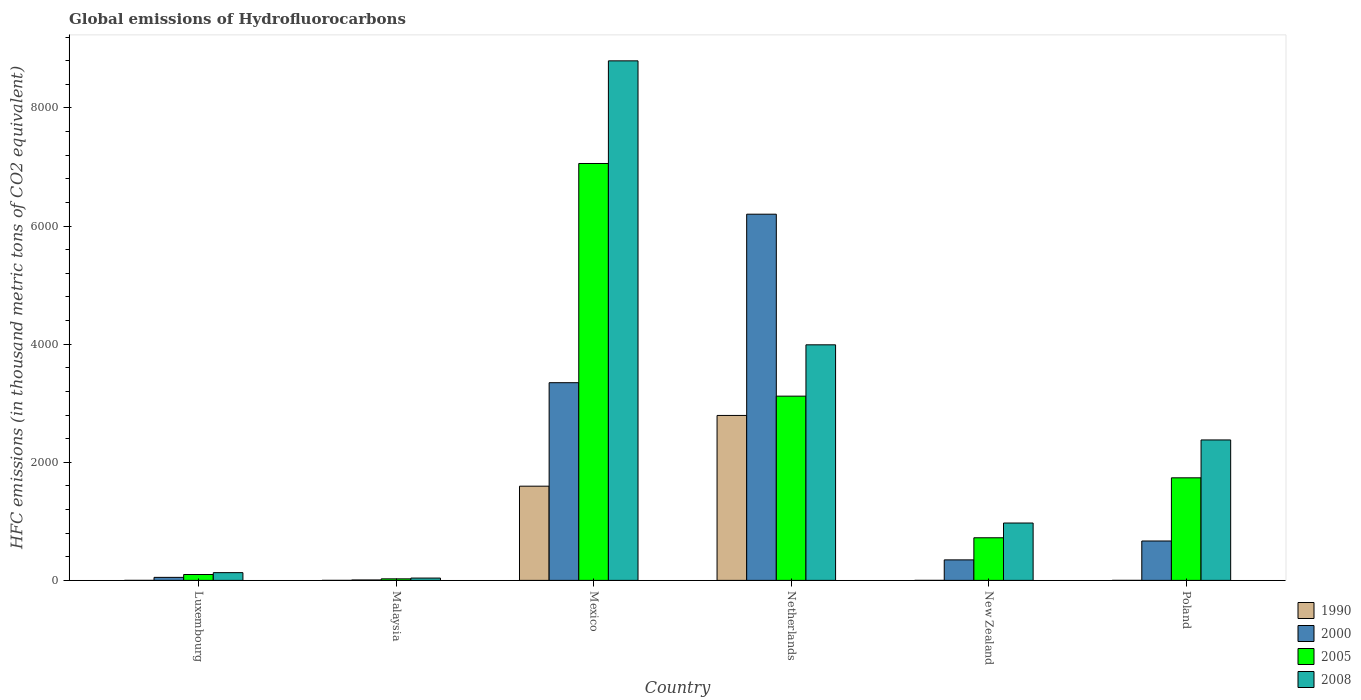How many different coloured bars are there?
Provide a short and direct response. 4. Are the number of bars on each tick of the X-axis equal?
Offer a very short reply. Yes. What is the label of the 4th group of bars from the left?
Offer a terse response. Netherlands. What is the global emissions of Hydrofluorocarbons in 2000 in Luxembourg?
Your response must be concise. 51.1. Across all countries, what is the maximum global emissions of Hydrofluorocarbons in 1990?
Keep it short and to the point. 2792.9. Across all countries, what is the minimum global emissions of Hydrofluorocarbons in 2005?
Your answer should be compact. 26.1. In which country was the global emissions of Hydrofluorocarbons in 2005 minimum?
Offer a very short reply. Malaysia. What is the total global emissions of Hydrofluorocarbons in 1990 in the graph?
Keep it short and to the point. 4388.7. What is the difference between the global emissions of Hydrofluorocarbons in 2005 in Mexico and that in Poland?
Offer a very short reply. 5322.2. What is the difference between the global emissions of Hydrofluorocarbons in 1990 in Malaysia and the global emissions of Hydrofluorocarbons in 2000 in Mexico?
Offer a very short reply. -3347.2. What is the average global emissions of Hydrofluorocarbons in 2000 per country?
Your answer should be compact. 1770.03. What is the difference between the global emissions of Hydrofluorocarbons of/in 2005 and global emissions of Hydrofluorocarbons of/in 2000 in Malaysia?
Provide a short and direct response. 19.2. In how many countries, is the global emissions of Hydrofluorocarbons in 1990 greater than 4800 thousand metric tons?
Make the answer very short. 0. What is the ratio of the global emissions of Hydrofluorocarbons in 2000 in Malaysia to that in New Zealand?
Your answer should be compact. 0.02. Is the global emissions of Hydrofluorocarbons in 1990 in Malaysia less than that in Poland?
Provide a succinct answer. No. What is the difference between the highest and the second highest global emissions of Hydrofluorocarbons in 2000?
Your answer should be compact. 2853.1. What is the difference between the highest and the lowest global emissions of Hydrofluorocarbons in 2000?
Ensure brevity in your answer.  6193.5. In how many countries, is the global emissions of Hydrofluorocarbons in 1990 greater than the average global emissions of Hydrofluorocarbons in 1990 taken over all countries?
Make the answer very short. 2. Is the sum of the global emissions of Hydrofluorocarbons in 2005 in Netherlands and New Zealand greater than the maximum global emissions of Hydrofluorocarbons in 2008 across all countries?
Provide a short and direct response. No. Is it the case that in every country, the sum of the global emissions of Hydrofluorocarbons in 2005 and global emissions of Hydrofluorocarbons in 1990 is greater than the sum of global emissions of Hydrofluorocarbons in 2008 and global emissions of Hydrofluorocarbons in 2000?
Give a very brief answer. No. What does the 2nd bar from the right in Mexico represents?
Your response must be concise. 2005. Are all the bars in the graph horizontal?
Offer a very short reply. No. What is the difference between two consecutive major ticks on the Y-axis?
Provide a short and direct response. 2000. Are the values on the major ticks of Y-axis written in scientific E-notation?
Ensure brevity in your answer.  No. Does the graph contain any zero values?
Your answer should be compact. No. How many legend labels are there?
Your answer should be very brief. 4. How are the legend labels stacked?
Your response must be concise. Vertical. What is the title of the graph?
Your answer should be compact. Global emissions of Hydrofluorocarbons. What is the label or title of the Y-axis?
Give a very brief answer. HFC emissions (in thousand metric tons of CO2 equivalent). What is the HFC emissions (in thousand metric tons of CO2 equivalent) of 1990 in Luxembourg?
Offer a very short reply. 0.1. What is the HFC emissions (in thousand metric tons of CO2 equivalent) in 2000 in Luxembourg?
Your answer should be very brief. 51.1. What is the HFC emissions (in thousand metric tons of CO2 equivalent) of 2005 in Luxembourg?
Provide a succinct answer. 99.5. What is the HFC emissions (in thousand metric tons of CO2 equivalent) of 2008 in Luxembourg?
Give a very brief answer. 131.2. What is the HFC emissions (in thousand metric tons of CO2 equivalent) in 2005 in Malaysia?
Ensure brevity in your answer.  26.1. What is the HFC emissions (in thousand metric tons of CO2 equivalent) of 2008 in Malaysia?
Offer a terse response. 39.2. What is the HFC emissions (in thousand metric tons of CO2 equivalent) in 1990 in Mexico?
Your response must be concise. 1595.3. What is the HFC emissions (in thousand metric tons of CO2 equivalent) in 2000 in Mexico?
Provide a short and direct response. 3347.3. What is the HFC emissions (in thousand metric tons of CO2 equivalent) of 2005 in Mexico?
Offer a terse response. 7058.9. What is the HFC emissions (in thousand metric tons of CO2 equivalent) of 2008 in Mexico?
Ensure brevity in your answer.  8796.9. What is the HFC emissions (in thousand metric tons of CO2 equivalent) of 1990 in Netherlands?
Your answer should be very brief. 2792.9. What is the HFC emissions (in thousand metric tons of CO2 equivalent) of 2000 in Netherlands?
Keep it short and to the point. 6200.4. What is the HFC emissions (in thousand metric tons of CO2 equivalent) of 2005 in Netherlands?
Provide a succinct answer. 3119.5. What is the HFC emissions (in thousand metric tons of CO2 equivalent) in 2008 in Netherlands?
Your answer should be very brief. 3988.8. What is the HFC emissions (in thousand metric tons of CO2 equivalent) of 2000 in New Zealand?
Offer a very short reply. 347.3. What is the HFC emissions (in thousand metric tons of CO2 equivalent) of 2005 in New Zealand?
Offer a terse response. 721.7. What is the HFC emissions (in thousand metric tons of CO2 equivalent) in 2008 in New Zealand?
Offer a very short reply. 971.4. What is the HFC emissions (in thousand metric tons of CO2 equivalent) in 2000 in Poland?
Give a very brief answer. 667.2. What is the HFC emissions (in thousand metric tons of CO2 equivalent) of 2005 in Poland?
Ensure brevity in your answer.  1736.7. What is the HFC emissions (in thousand metric tons of CO2 equivalent) of 2008 in Poland?
Your answer should be very brief. 2378. Across all countries, what is the maximum HFC emissions (in thousand metric tons of CO2 equivalent) in 1990?
Keep it short and to the point. 2792.9. Across all countries, what is the maximum HFC emissions (in thousand metric tons of CO2 equivalent) in 2000?
Your response must be concise. 6200.4. Across all countries, what is the maximum HFC emissions (in thousand metric tons of CO2 equivalent) of 2005?
Give a very brief answer. 7058.9. Across all countries, what is the maximum HFC emissions (in thousand metric tons of CO2 equivalent) of 2008?
Your answer should be very brief. 8796.9. Across all countries, what is the minimum HFC emissions (in thousand metric tons of CO2 equivalent) in 1990?
Provide a succinct answer. 0.1. Across all countries, what is the minimum HFC emissions (in thousand metric tons of CO2 equivalent) in 2005?
Provide a short and direct response. 26.1. Across all countries, what is the minimum HFC emissions (in thousand metric tons of CO2 equivalent) in 2008?
Offer a very short reply. 39.2. What is the total HFC emissions (in thousand metric tons of CO2 equivalent) of 1990 in the graph?
Offer a terse response. 4388.7. What is the total HFC emissions (in thousand metric tons of CO2 equivalent) in 2000 in the graph?
Your answer should be very brief. 1.06e+04. What is the total HFC emissions (in thousand metric tons of CO2 equivalent) of 2005 in the graph?
Offer a terse response. 1.28e+04. What is the total HFC emissions (in thousand metric tons of CO2 equivalent) of 2008 in the graph?
Your answer should be very brief. 1.63e+04. What is the difference between the HFC emissions (in thousand metric tons of CO2 equivalent) of 1990 in Luxembourg and that in Malaysia?
Ensure brevity in your answer.  0. What is the difference between the HFC emissions (in thousand metric tons of CO2 equivalent) of 2000 in Luxembourg and that in Malaysia?
Make the answer very short. 44.2. What is the difference between the HFC emissions (in thousand metric tons of CO2 equivalent) of 2005 in Luxembourg and that in Malaysia?
Provide a short and direct response. 73.4. What is the difference between the HFC emissions (in thousand metric tons of CO2 equivalent) of 2008 in Luxembourg and that in Malaysia?
Give a very brief answer. 92. What is the difference between the HFC emissions (in thousand metric tons of CO2 equivalent) in 1990 in Luxembourg and that in Mexico?
Give a very brief answer. -1595.2. What is the difference between the HFC emissions (in thousand metric tons of CO2 equivalent) in 2000 in Luxembourg and that in Mexico?
Provide a short and direct response. -3296.2. What is the difference between the HFC emissions (in thousand metric tons of CO2 equivalent) in 2005 in Luxembourg and that in Mexico?
Make the answer very short. -6959.4. What is the difference between the HFC emissions (in thousand metric tons of CO2 equivalent) of 2008 in Luxembourg and that in Mexico?
Provide a short and direct response. -8665.7. What is the difference between the HFC emissions (in thousand metric tons of CO2 equivalent) in 1990 in Luxembourg and that in Netherlands?
Your answer should be very brief. -2792.8. What is the difference between the HFC emissions (in thousand metric tons of CO2 equivalent) in 2000 in Luxembourg and that in Netherlands?
Your answer should be very brief. -6149.3. What is the difference between the HFC emissions (in thousand metric tons of CO2 equivalent) of 2005 in Luxembourg and that in Netherlands?
Your response must be concise. -3020. What is the difference between the HFC emissions (in thousand metric tons of CO2 equivalent) in 2008 in Luxembourg and that in Netherlands?
Give a very brief answer. -3857.6. What is the difference between the HFC emissions (in thousand metric tons of CO2 equivalent) of 1990 in Luxembourg and that in New Zealand?
Provide a short and direct response. -0.1. What is the difference between the HFC emissions (in thousand metric tons of CO2 equivalent) of 2000 in Luxembourg and that in New Zealand?
Make the answer very short. -296.2. What is the difference between the HFC emissions (in thousand metric tons of CO2 equivalent) of 2005 in Luxembourg and that in New Zealand?
Give a very brief answer. -622.2. What is the difference between the HFC emissions (in thousand metric tons of CO2 equivalent) in 2008 in Luxembourg and that in New Zealand?
Offer a very short reply. -840.2. What is the difference between the HFC emissions (in thousand metric tons of CO2 equivalent) in 1990 in Luxembourg and that in Poland?
Offer a very short reply. 0. What is the difference between the HFC emissions (in thousand metric tons of CO2 equivalent) of 2000 in Luxembourg and that in Poland?
Ensure brevity in your answer.  -616.1. What is the difference between the HFC emissions (in thousand metric tons of CO2 equivalent) of 2005 in Luxembourg and that in Poland?
Provide a succinct answer. -1637.2. What is the difference between the HFC emissions (in thousand metric tons of CO2 equivalent) of 2008 in Luxembourg and that in Poland?
Give a very brief answer. -2246.8. What is the difference between the HFC emissions (in thousand metric tons of CO2 equivalent) in 1990 in Malaysia and that in Mexico?
Your response must be concise. -1595.2. What is the difference between the HFC emissions (in thousand metric tons of CO2 equivalent) in 2000 in Malaysia and that in Mexico?
Keep it short and to the point. -3340.4. What is the difference between the HFC emissions (in thousand metric tons of CO2 equivalent) in 2005 in Malaysia and that in Mexico?
Offer a very short reply. -7032.8. What is the difference between the HFC emissions (in thousand metric tons of CO2 equivalent) in 2008 in Malaysia and that in Mexico?
Your response must be concise. -8757.7. What is the difference between the HFC emissions (in thousand metric tons of CO2 equivalent) of 1990 in Malaysia and that in Netherlands?
Provide a short and direct response. -2792.8. What is the difference between the HFC emissions (in thousand metric tons of CO2 equivalent) of 2000 in Malaysia and that in Netherlands?
Offer a terse response. -6193.5. What is the difference between the HFC emissions (in thousand metric tons of CO2 equivalent) in 2005 in Malaysia and that in Netherlands?
Your answer should be compact. -3093.4. What is the difference between the HFC emissions (in thousand metric tons of CO2 equivalent) in 2008 in Malaysia and that in Netherlands?
Keep it short and to the point. -3949.6. What is the difference between the HFC emissions (in thousand metric tons of CO2 equivalent) of 2000 in Malaysia and that in New Zealand?
Offer a very short reply. -340.4. What is the difference between the HFC emissions (in thousand metric tons of CO2 equivalent) in 2005 in Malaysia and that in New Zealand?
Your answer should be compact. -695.6. What is the difference between the HFC emissions (in thousand metric tons of CO2 equivalent) of 2008 in Malaysia and that in New Zealand?
Offer a very short reply. -932.2. What is the difference between the HFC emissions (in thousand metric tons of CO2 equivalent) in 2000 in Malaysia and that in Poland?
Offer a terse response. -660.3. What is the difference between the HFC emissions (in thousand metric tons of CO2 equivalent) of 2005 in Malaysia and that in Poland?
Make the answer very short. -1710.6. What is the difference between the HFC emissions (in thousand metric tons of CO2 equivalent) in 2008 in Malaysia and that in Poland?
Ensure brevity in your answer.  -2338.8. What is the difference between the HFC emissions (in thousand metric tons of CO2 equivalent) of 1990 in Mexico and that in Netherlands?
Offer a very short reply. -1197.6. What is the difference between the HFC emissions (in thousand metric tons of CO2 equivalent) in 2000 in Mexico and that in Netherlands?
Keep it short and to the point. -2853.1. What is the difference between the HFC emissions (in thousand metric tons of CO2 equivalent) in 2005 in Mexico and that in Netherlands?
Give a very brief answer. 3939.4. What is the difference between the HFC emissions (in thousand metric tons of CO2 equivalent) in 2008 in Mexico and that in Netherlands?
Ensure brevity in your answer.  4808.1. What is the difference between the HFC emissions (in thousand metric tons of CO2 equivalent) of 1990 in Mexico and that in New Zealand?
Ensure brevity in your answer.  1595.1. What is the difference between the HFC emissions (in thousand metric tons of CO2 equivalent) of 2000 in Mexico and that in New Zealand?
Provide a short and direct response. 3000. What is the difference between the HFC emissions (in thousand metric tons of CO2 equivalent) of 2005 in Mexico and that in New Zealand?
Ensure brevity in your answer.  6337.2. What is the difference between the HFC emissions (in thousand metric tons of CO2 equivalent) of 2008 in Mexico and that in New Zealand?
Make the answer very short. 7825.5. What is the difference between the HFC emissions (in thousand metric tons of CO2 equivalent) of 1990 in Mexico and that in Poland?
Provide a succinct answer. 1595.2. What is the difference between the HFC emissions (in thousand metric tons of CO2 equivalent) in 2000 in Mexico and that in Poland?
Offer a terse response. 2680.1. What is the difference between the HFC emissions (in thousand metric tons of CO2 equivalent) of 2005 in Mexico and that in Poland?
Offer a very short reply. 5322.2. What is the difference between the HFC emissions (in thousand metric tons of CO2 equivalent) in 2008 in Mexico and that in Poland?
Provide a succinct answer. 6418.9. What is the difference between the HFC emissions (in thousand metric tons of CO2 equivalent) in 1990 in Netherlands and that in New Zealand?
Keep it short and to the point. 2792.7. What is the difference between the HFC emissions (in thousand metric tons of CO2 equivalent) in 2000 in Netherlands and that in New Zealand?
Offer a very short reply. 5853.1. What is the difference between the HFC emissions (in thousand metric tons of CO2 equivalent) in 2005 in Netherlands and that in New Zealand?
Provide a short and direct response. 2397.8. What is the difference between the HFC emissions (in thousand metric tons of CO2 equivalent) of 2008 in Netherlands and that in New Zealand?
Make the answer very short. 3017.4. What is the difference between the HFC emissions (in thousand metric tons of CO2 equivalent) of 1990 in Netherlands and that in Poland?
Your response must be concise. 2792.8. What is the difference between the HFC emissions (in thousand metric tons of CO2 equivalent) of 2000 in Netherlands and that in Poland?
Make the answer very short. 5533.2. What is the difference between the HFC emissions (in thousand metric tons of CO2 equivalent) in 2005 in Netherlands and that in Poland?
Offer a terse response. 1382.8. What is the difference between the HFC emissions (in thousand metric tons of CO2 equivalent) in 2008 in Netherlands and that in Poland?
Offer a terse response. 1610.8. What is the difference between the HFC emissions (in thousand metric tons of CO2 equivalent) of 1990 in New Zealand and that in Poland?
Give a very brief answer. 0.1. What is the difference between the HFC emissions (in thousand metric tons of CO2 equivalent) of 2000 in New Zealand and that in Poland?
Your answer should be very brief. -319.9. What is the difference between the HFC emissions (in thousand metric tons of CO2 equivalent) in 2005 in New Zealand and that in Poland?
Offer a terse response. -1015. What is the difference between the HFC emissions (in thousand metric tons of CO2 equivalent) in 2008 in New Zealand and that in Poland?
Give a very brief answer. -1406.6. What is the difference between the HFC emissions (in thousand metric tons of CO2 equivalent) of 1990 in Luxembourg and the HFC emissions (in thousand metric tons of CO2 equivalent) of 2000 in Malaysia?
Keep it short and to the point. -6.8. What is the difference between the HFC emissions (in thousand metric tons of CO2 equivalent) in 1990 in Luxembourg and the HFC emissions (in thousand metric tons of CO2 equivalent) in 2005 in Malaysia?
Give a very brief answer. -26. What is the difference between the HFC emissions (in thousand metric tons of CO2 equivalent) in 1990 in Luxembourg and the HFC emissions (in thousand metric tons of CO2 equivalent) in 2008 in Malaysia?
Offer a terse response. -39.1. What is the difference between the HFC emissions (in thousand metric tons of CO2 equivalent) of 2005 in Luxembourg and the HFC emissions (in thousand metric tons of CO2 equivalent) of 2008 in Malaysia?
Ensure brevity in your answer.  60.3. What is the difference between the HFC emissions (in thousand metric tons of CO2 equivalent) of 1990 in Luxembourg and the HFC emissions (in thousand metric tons of CO2 equivalent) of 2000 in Mexico?
Provide a short and direct response. -3347.2. What is the difference between the HFC emissions (in thousand metric tons of CO2 equivalent) in 1990 in Luxembourg and the HFC emissions (in thousand metric tons of CO2 equivalent) in 2005 in Mexico?
Your response must be concise. -7058.8. What is the difference between the HFC emissions (in thousand metric tons of CO2 equivalent) in 1990 in Luxembourg and the HFC emissions (in thousand metric tons of CO2 equivalent) in 2008 in Mexico?
Provide a succinct answer. -8796.8. What is the difference between the HFC emissions (in thousand metric tons of CO2 equivalent) in 2000 in Luxembourg and the HFC emissions (in thousand metric tons of CO2 equivalent) in 2005 in Mexico?
Your answer should be very brief. -7007.8. What is the difference between the HFC emissions (in thousand metric tons of CO2 equivalent) of 2000 in Luxembourg and the HFC emissions (in thousand metric tons of CO2 equivalent) of 2008 in Mexico?
Your answer should be very brief. -8745.8. What is the difference between the HFC emissions (in thousand metric tons of CO2 equivalent) of 2005 in Luxembourg and the HFC emissions (in thousand metric tons of CO2 equivalent) of 2008 in Mexico?
Your response must be concise. -8697.4. What is the difference between the HFC emissions (in thousand metric tons of CO2 equivalent) in 1990 in Luxembourg and the HFC emissions (in thousand metric tons of CO2 equivalent) in 2000 in Netherlands?
Offer a very short reply. -6200.3. What is the difference between the HFC emissions (in thousand metric tons of CO2 equivalent) in 1990 in Luxembourg and the HFC emissions (in thousand metric tons of CO2 equivalent) in 2005 in Netherlands?
Make the answer very short. -3119.4. What is the difference between the HFC emissions (in thousand metric tons of CO2 equivalent) in 1990 in Luxembourg and the HFC emissions (in thousand metric tons of CO2 equivalent) in 2008 in Netherlands?
Give a very brief answer. -3988.7. What is the difference between the HFC emissions (in thousand metric tons of CO2 equivalent) in 2000 in Luxembourg and the HFC emissions (in thousand metric tons of CO2 equivalent) in 2005 in Netherlands?
Make the answer very short. -3068.4. What is the difference between the HFC emissions (in thousand metric tons of CO2 equivalent) in 2000 in Luxembourg and the HFC emissions (in thousand metric tons of CO2 equivalent) in 2008 in Netherlands?
Your response must be concise. -3937.7. What is the difference between the HFC emissions (in thousand metric tons of CO2 equivalent) of 2005 in Luxembourg and the HFC emissions (in thousand metric tons of CO2 equivalent) of 2008 in Netherlands?
Ensure brevity in your answer.  -3889.3. What is the difference between the HFC emissions (in thousand metric tons of CO2 equivalent) in 1990 in Luxembourg and the HFC emissions (in thousand metric tons of CO2 equivalent) in 2000 in New Zealand?
Offer a very short reply. -347.2. What is the difference between the HFC emissions (in thousand metric tons of CO2 equivalent) in 1990 in Luxembourg and the HFC emissions (in thousand metric tons of CO2 equivalent) in 2005 in New Zealand?
Your answer should be compact. -721.6. What is the difference between the HFC emissions (in thousand metric tons of CO2 equivalent) of 1990 in Luxembourg and the HFC emissions (in thousand metric tons of CO2 equivalent) of 2008 in New Zealand?
Offer a terse response. -971.3. What is the difference between the HFC emissions (in thousand metric tons of CO2 equivalent) in 2000 in Luxembourg and the HFC emissions (in thousand metric tons of CO2 equivalent) in 2005 in New Zealand?
Your answer should be very brief. -670.6. What is the difference between the HFC emissions (in thousand metric tons of CO2 equivalent) in 2000 in Luxembourg and the HFC emissions (in thousand metric tons of CO2 equivalent) in 2008 in New Zealand?
Your answer should be very brief. -920.3. What is the difference between the HFC emissions (in thousand metric tons of CO2 equivalent) in 2005 in Luxembourg and the HFC emissions (in thousand metric tons of CO2 equivalent) in 2008 in New Zealand?
Keep it short and to the point. -871.9. What is the difference between the HFC emissions (in thousand metric tons of CO2 equivalent) of 1990 in Luxembourg and the HFC emissions (in thousand metric tons of CO2 equivalent) of 2000 in Poland?
Your answer should be very brief. -667.1. What is the difference between the HFC emissions (in thousand metric tons of CO2 equivalent) in 1990 in Luxembourg and the HFC emissions (in thousand metric tons of CO2 equivalent) in 2005 in Poland?
Provide a short and direct response. -1736.6. What is the difference between the HFC emissions (in thousand metric tons of CO2 equivalent) in 1990 in Luxembourg and the HFC emissions (in thousand metric tons of CO2 equivalent) in 2008 in Poland?
Give a very brief answer. -2377.9. What is the difference between the HFC emissions (in thousand metric tons of CO2 equivalent) in 2000 in Luxembourg and the HFC emissions (in thousand metric tons of CO2 equivalent) in 2005 in Poland?
Your answer should be very brief. -1685.6. What is the difference between the HFC emissions (in thousand metric tons of CO2 equivalent) of 2000 in Luxembourg and the HFC emissions (in thousand metric tons of CO2 equivalent) of 2008 in Poland?
Offer a terse response. -2326.9. What is the difference between the HFC emissions (in thousand metric tons of CO2 equivalent) of 2005 in Luxembourg and the HFC emissions (in thousand metric tons of CO2 equivalent) of 2008 in Poland?
Your answer should be compact. -2278.5. What is the difference between the HFC emissions (in thousand metric tons of CO2 equivalent) of 1990 in Malaysia and the HFC emissions (in thousand metric tons of CO2 equivalent) of 2000 in Mexico?
Give a very brief answer. -3347.2. What is the difference between the HFC emissions (in thousand metric tons of CO2 equivalent) of 1990 in Malaysia and the HFC emissions (in thousand metric tons of CO2 equivalent) of 2005 in Mexico?
Your answer should be very brief. -7058.8. What is the difference between the HFC emissions (in thousand metric tons of CO2 equivalent) in 1990 in Malaysia and the HFC emissions (in thousand metric tons of CO2 equivalent) in 2008 in Mexico?
Your response must be concise. -8796.8. What is the difference between the HFC emissions (in thousand metric tons of CO2 equivalent) in 2000 in Malaysia and the HFC emissions (in thousand metric tons of CO2 equivalent) in 2005 in Mexico?
Your answer should be very brief. -7052. What is the difference between the HFC emissions (in thousand metric tons of CO2 equivalent) in 2000 in Malaysia and the HFC emissions (in thousand metric tons of CO2 equivalent) in 2008 in Mexico?
Offer a very short reply. -8790. What is the difference between the HFC emissions (in thousand metric tons of CO2 equivalent) in 2005 in Malaysia and the HFC emissions (in thousand metric tons of CO2 equivalent) in 2008 in Mexico?
Offer a very short reply. -8770.8. What is the difference between the HFC emissions (in thousand metric tons of CO2 equivalent) in 1990 in Malaysia and the HFC emissions (in thousand metric tons of CO2 equivalent) in 2000 in Netherlands?
Offer a terse response. -6200.3. What is the difference between the HFC emissions (in thousand metric tons of CO2 equivalent) in 1990 in Malaysia and the HFC emissions (in thousand metric tons of CO2 equivalent) in 2005 in Netherlands?
Offer a very short reply. -3119.4. What is the difference between the HFC emissions (in thousand metric tons of CO2 equivalent) in 1990 in Malaysia and the HFC emissions (in thousand metric tons of CO2 equivalent) in 2008 in Netherlands?
Offer a very short reply. -3988.7. What is the difference between the HFC emissions (in thousand metric tons of CO2 equivalent) of 2000 in Malaysia and the HFC emissions (in thousand metric tons of CO2 equivalent) of 2005 in Netherlands?
Ensure brevity in your answer.  -3112.6. What is the difference between the HFC emissions (in thousand metric tons of CO2 equivalent) of 2000 in Malaysia and the HFC emissions (in thousand metric tons of CO2 equivalent) of 2008 in Netherlands?
Make the answer very short. -3981.9. What is the difference between the HFC emissions (in thousand metric tons of CO2 equivalent) in 2005 in Malaysia and the HFC emissions (in thousand metric tons of CO2 equivalent) in 2008 in Netherlands?
Ensure brevity in your answer.  -3962.7. What is the difference between the HFC emissions (in thousand metric tons of CO2 equivalent) in 1990 in Malaysia and the HFC emissions (in thousand metric tons of CO2 equivalent) in 2000 in New Zealand?
Your answer should be very brief. -347.2. What is the difference between the HFC emissions (in thousand metric tons of CO2 equivalent) of 1990 in Malaysia and the HFC emissions (in thousand metric tons of CO2 equivalent) of 2005 in New Zealand?
Provide a succinct answer. -721.6. What is the difference between the HFC emissions (in thousand metric tons of CO2 equivalent) in 1990 in Malaysia and the HFC emissions (in thousand metric tons of CO2 equivalent) in 2008 in New Zealand?
Offer a terse response. -971.3. What is the difference between the HFC emissions (in thousand metric tons of CO2 equivalent) in 2000 in Malaysia and the HFC emissions (in thousand metric tons of CO2 equivalent) in 2005 in New Zealand?
Give a very brief answer. -714.8. What is the difference between the HFC emissions (in thousand metric tons of CO2 equivalent) of 2000 in Malaysia and the HFC emissions (in thousand metric tons of CO2 equivalent) of 2008 in New Zealand?
Give a very brief answer. -964.5. What is the difference between the HFC emissions (in thousand metric tons of CO2 equivalent) in 2005 in Malaysia and the HFC emissions (in thousand metric tons of CO2 equivalent) in 2008 in New Zealand?
Make the answer very short. -945.3. What is the difference between the HFC emissions (in thousand metric tons of CO2 equivalent) in 1990 in Malaysia and the HFC emissions (in thousand metric tons of CO2 equivalent) in 2000 in Poland?
Ensure brevity in your answer.  -667.1. What is the difference between the HFC emissions (in thousand metric tons of CO2 equivalent) in 1990 in Malaysia and the HFC emissions (in thousand metric tons of CO2 equivalent) in 2005 in Poland?
Give a very brief answer. -1736.6. What is the difference between the HFC emissions (in thousand metric tons of CO2 equivalent) in 1990 in Malaysia and the HFC emissions (in thousand metric tons of CO2 equivalent) in 2008 in Poland?
Keep it short and to the point. -2377.9. What is the difference between the HFC emissions (in thousand metric tons of CO2 equivalent) in 2000 in Malaysia and the HFC emissions (in thousand metric tons of CO2 equivalent) in 2005 in Poland?
Ensure brevity in your answer.  -1729.8. What is the difference between the HFC emissions (in thousand metric tons of CO2 equivalent) of 2000 in Malaysia and the HFC emissions (in thousand metric tons of CO2 equivalent) of 2008 in Poland?
Offer a terse response. -2371.1. What is the difference between the HFC emissions (in thousand metric tons of CO2 equivalent) in 2005 in Malaysia and the HFC emissions (in thousand metric tons of CO2 equivalent) in 2008 in Poland?
Your response must be concise. -2351.9. What is the difference between the HFC emissions (in thousand metric tons of CO2 equivalent) of 1990 in Mexico and the HFC emissions (in thousand metric tons of CO2 equivalent) of 2000 in Netherlands?
Make the answer very short. -4605.1. What is the difference between the HFC emissions (in thousand metric tons of CO2 equivalent) of 1990 in Mexico and the HFC emissions (in thousand metric tons of CO2 equivalent) of 2005 in Netherlands?
Your response must be concise. -1524.2. What is the difference between the HFC emissions (in thousand metric tons of CO2 equivalent) of 1990 in Mexico and the HFC emissions (in thousand metric tons of CO2 equivalent) of 2008 in Netherlands?
Offer a terse response. -2393.5. What is the difference between the HFC emissions (in thousand metric tons of CO2 equivalent) of 2000 in Mexico and the HFC emissions (in thousand metric tons of CO2 equivalent) of 2005 in Netherlands?
Offer a terse response. 227.8. What is the difference between the HFC emissions (in thousand metric tons of CO2 equivalent) of 2000 in Mexico and the HFC emissions (in thousand metric tons of CO2 equivalent) of 2008 in Netherlands?
Offer a very short reply. -641.5. What is the difference between the HFC emissions (in thousand metric tons of CO2 equivalent) in 2005 in Mexico and the HFC emissions (in thousand metric tons of CO2 equivalent) in 2008 in Netherlands?
Provide a succinct answer. 3070.1. What is the difference between the HFC emissions (in thousand metric tons of CO2 equivalent) in 1990 in Mexico and the HFC emissions (in thousand metric tons of CO2 equivalent) in 2000 in New Zealand?
Your answer should be very brief. 1248. What is the difference between the HFC emissions (in thousand metric tons of CO2 equivalent) in 1990 in Mexico and the HFC emissions (in thousand metric tons of CO2 equivalent) in 2005 in New Zealand?
Your answer should be very brief. 873.6. What is the difference between the HFC emissions (in thousand metric tons of CO2 equivalent) of 1990 in Mexico and the HFC emissions (in thousand metric tons of CO2 equivalent) of 2008 in New Zealand?
Give a very brief answer. 623.9. What is the difference between the HFC emissions (in thousand metric tons of CO2 equivalent) in 2000 in Mexico and the HFC emissions (in thousand metric tons of CO2 equivalent) in 2005 in New Zealand?
Provide a succinct answer. 2625.6. What is the difference between the HFC emissions (in thousand metric tons of CO2 equivalent) in 2000 in Mexico and the HFC emissions (in thousand metric tons of CO2 equivalent) in 2008 in New Zealand?
Provide a succinct answer. 2375.9. What is the difference between the HFC emissions (in thousand metric tons of CO2 equivalent) in 2005 in Mexico and the HFC emissions (in thousand metric tons of CO2 equivalent) in 2008 in New Zealand?
Offer a very short reply. 6087.5. What is the difference between the HFC emissions (in thousand metric tons of CO2 equivalent) of 1990 in Mexico and the HFC emissions (in thousand metric tons of CO2 equivalent) of 2000 in Poland?
Provide a succinct answer. 928.1. What is the difference between the HFC emissions (in thousand metric tons of CO2 equivalent) in 1990 in Mexico and the HFC emissions (in thousand metric tons of CO2 equivalent) in 2005 in Poland?
Offer a very short reply. -141.4. What is the difference between the HFC emissions (in thousand metric tons of CO2 equivalent) of 1990 in Mexico and the HFC emissions (in thousand metric tons of CO2 equivalent) of 2008 in Poland?
Provide a short and direct response. -782.7. What is the difference between the HFC emissions (in thousand metric tons of CO2 equivalent) in 2000 in Mexico and the HFC emissions (in thousand metric tons of CO2 equivalent) in 2005 in Poland?
Your answer should be very brief. 1610.6. What is the difference between the HFC emissions (in thousand metric tons of CO2 equivalent) in 2000 in Mexico and the HFC emissions (in thousand metric tons of CO2 equivalent) in 2008 in Poland?
Make the answer very short. 969.3. What is the difference between the HFC emissions (in thousand metric tons of CO2 equivalent) of 2005 in Mexico and the HFC emissions (in thousand metric tons of CO2 equivalent) of 2008 in Poland?
Provide a succinct answer. 4680.9. What is the difference between the HFC emissions (in thousand metric tons of CO2 equivalent) in 1990 in Netherlands and the HFC emissions (in thousand metric tons of CO2 equivalent) in 2000 in New Zealand?
Your answer should be compact. 2445.6. What is the difference between the HFC emissions (in thousand metric tons of CO2 equivalent) in 1990 in Netherlands and the HFC emissions (in thousand metric tons of CO2 equivalent) in 2005 in New Zealand?
Keep it short and to the point. 2071.2. What is the difference between the HFC emissions (in thousand metric tons of CO2 equivalent) in 1990 in Netherlands and the HFC emissions (in thousand metric tons of CO2 equivalent) in 2008 in New Zealand?
Your response must be concise. 1821.5. What is the difference between the HFC emissions (in thousand metric tons of CO2 equivalent) in 2000 in Netherlands and the HFC emissions (in thousand metric tons of CO2 equivalent) in 2005 in New Zealand?
Provide a succinct answer. 5478.7. What is the difference between the HFC emissions (in thousand metric tons of CO2 equivalent) in 2000 in Netherlands and the HFC emissions (in thousand metric tons of CO2 equivalent) in 2008 in New Zealand?
Your answer should be compact. 5229. What is the difference between the HFC emissions (in thousand metric tons of CO2 equivalent) in 2005 in Netherlands and the HFC emissions (in thousand metric tons of CO2 equivalent) in 2008 in New Zealand?
Ensure brevity in your answer.  2148.1. What is the difference between the HFC emissions (in thousand metric tons of CO2 equivalent) in 1990 in Netherlands and the HFC emissions (in thousand metric tons of CO2 equivalent) in 2000 in Poland?
Offer a terse response. 2125.7. What is the difference between the HFC emissions (in thousand metric tons of CO2 equivalent) in 1990 in Netherlands and the HFC emissions (in thousand metric tons of CO2 equivalent) in 2005 in Poland?
Offer a terse response. 1056.2. What is the difference between the HFC emissions (in thousand metric tons of CO2 equivalent) of 1990 in Netherlands and the HFC emissions (in thousand metric tons of CO2 equivalent) of 2008 in Poland?
Provide a short and direct response. 414.9. What is the difference between the HFC emissions (in thousand metric tons of CO2 equivalent) in 2000 in Netherlands and the HFC emissions (in thousand metric tons of CO2 equivalent) in 2005 in Poland?
Make the answer very short. 4463.7. What is the difference between the HFC emissions (in thousand metric tons of CO2 equivalent) in 2000 in Netherlands and the HFC emissions (in thousand metric tons of CO2 equivalent) in 2008 in Poland?
Your response must be concise. 3822.4. What is the difference between the HFC emissions (in thousand metric tons of CO2 equivalent) in 2005 in Netherlands and the HFC emissions (in thousand metric tons of CO2 equivalent) in 2008 in Poland?
Provide a short and direct response. 741.5. What is the difference between the HFC emissions (in thousand metric tons of CO2 equivalent) in 1990 in New Zealand and the HFC emissions (in thousand metric tons of CO2 equivalent) in 2000 in Poland?
Keep it short and to the point. -667. What is the difference between the HFC emissions (in thousand metric tons of CO2 equivalent) in 1990 in New Zealand and the HFC emissions (in thousand metric tons of CO2 equivalent) in 2005 in Poland?
Your answer should be compact. -1736.5. What is the difference between the HFC emissions (in thousand metric tons of CO2 equivalent) of 1990 in New Zealand and the HFC emissions (in thousand metric tons of CO2 equivalent) of 2008 in Poland?
Keep it short and to the point. -2377.8. What is the difference between the HFC emissions (in thousand metric tons of CO2 equivalent) in 2000 in New Zealand and the HFC emissions (in thousand metric tons of CO2 equivalent) in 2005 in Poland?
Your answer should be very brief. -1389.4. What is the difference between the HFC emissions (in thousand metric tons of CO2 equivalent) of 2000 in New Zealand and the HFC emissions (in thousand metric tons of CO2 equivalent) of 2008 in Poland?
Offer a very short reply. -2030.7. What is the difference between the HFC emissions (in thousand metric tons of CO2 equivalent) in 2005 in New Zealand and the HFC emissions (in thousand metric tons of CO2 equivalent) in 2008 in Poland?
Give a very brief answer. -1656.3. What is the average HFC emissions (in thousand metric tons of CO2 equivalent) in 1990 per country?
Make the answer very short. 731.45. What is the average HFC emissions (in thousand metric tons of CO2 equivalent) of 2000 per country?
Offer a terse response. 1770.03. What is the average HFC emissions (in thousand metric tons of CO2 equivalent) of 2005 per country?
Make the answer very short. 2127.07. What is the average HFC emissions (in thousand metric tons of CO2 equivalent) of 2008 per country?
Make the answer very short. 2717.58. What is the difference between the HFC emissions (in thousand metric tons of CO2 equivalent) in 1990 and HFC emissions (in thousand metric tons of CO2 equivalent) in 2000 in Luxembourg?
Keep it short and to the point. -51. What is the difference between the HFC emissions (in thousand metric tons of CO2 equivalent) of 1990 and HFC emissions (in thousand metric tons of CO2 equivalent) of 2005 in Luxembourg?
Provide a succinct answer. -99.4. What is the difference between the HFC emissions (in thousand metric tons of CO2 equivalent) of 1990 and HFC emissions (in thousand metric tons of CO2 equivalent) of 2008 in Luxembourg?
Ensure brevity in your answer.  -131.1. What is the difference between the HFC emissions (in thousand metric tons of CO2 equivalent) in 2000 and HFC emissions (in thousand metric tons of CO2 equivalent) in 2005 in Luxembourg?
Your response must be concise. -48.4. What is the difference between the HFC emissions (in thousand metric tons of CO2 equivalent) of 2000 and HFC emissions (in thousand metric tons of CO2 equivalent) of 2008 in Luxembourg?
Offer a terse response. -80.1. What is the difference between the HFC emissions (in thousand metric tons of CO2 equivalent) in 2005 and HFC emissions (in thousand metric tons of CO2 equivalent) in 2008 in Luxembourg?
Make the answer very short. -31.7. What is the difference between the HFC emissions (in thousand metric tons of CO2 equivalent) in 1990 and HFC emissions (in thousand metric tons of CO2 equivalent) in 2008 in Malaysia?
Offer a terse response. -39.1. What is the difference between the HFC emissions (in thousand metric tons of CO2 equivalent) of 2000 and HFC emissions (in thousand metric tons of CO2 equivalent) of 2005 in Malaysia?
Provide a short and direct response. -19.2. What is the difference between the HFC emissions (in thousand metric tons of CO2 equivalent) in 2000 and HFC emissions (in thousand metric tons of CO2 equivalent) in 2008 in Malaysia?
Provide a short and direct response. -32.3. What is the difference between the HFC emissions (in thousand metric tons of CO2 equivalent) of 1990 and HFC emissions (in thousand metric tons of CO2 equivalent) of 2000 in Mexico?
Your answer should be very brief. -1752. What is the difference between the HFC emissions (in thousand metric tons of CO2 equivalent) in 1990 and HFC emissions (in thousand metric tons of CO2 equivalent) in 2005 in Mexico?
Provide a short and direct response. -5463.6. What is the difference between the HFC emissions (in thousand metric tons of CO2 equivalent) in 1990 and HFC emissions (in thousand metric tons of CO2 equivalent) in 2008 in Mexico?
Make the answer very short. -7201.6. What is the difference between the HFC emissions (in thousand metric tons of CO2 equivalent) of 2000 and HFC emissions (in thousand metric tons of CO2 equivalent) of 2005 in Mexico?
Your answer should be very brief. -3711.6. What is the difference between the HFC emissions (in thousand metric tons of CO2 equivalent) in 2000 and HFC emissions (in thousand metric tons of CO2 equivalent) in 2008 in Mexico?
Provide a short and direct response. -5449.6. What is the difference between the HFC emissions (in thousand metric tons of CO2 equivalent) of 2005 and HFC emissions (in thousand metric tons of CO2 equivalent) of 2008 in Mexico?
Your answer should be very brief. -1738. What is the difference between the HFC emissions (in thousand metric tons of CO2 equivalent) in 1990 and HFC emissions (in thousand metric tons of CO2 equivalent) in 2000 in Netherlands?
Your answer should be very brief. -3407.5. What is the difference between the HFC emissions (in thousand metric tons of CO2 equivalent) of 1990 and HFC emissions (in thousand metric tons of CO2 equivalent) of 2005 in Netherlands?
Provide a succinct answer. -326.6. What is the difference between the HFC emissions (in thousand metric tons of CO2 equivalent) of 1990 and HFC emissions (in thousand metric tons of CO2 equivalent) of 2008 in Netherlands?
Your response must be concise. -1195.9. What is the difference between the HFC emissions (in thousand metric tons of CO2 equivalent) of 2000 and HFC emissions (in thousand metric tons of CO2 equivalent) of 2005 in Netherlands?
Offer a terse response. 3080.9. What is the difference between the HFC emissions (in thousand metric tons of CO2 equivalent) of 2000 and HFC emissions (in thousand metric tons of CO2 equivalent) of 2008 in Netherlands?
Make the answer very short. 2211.6. What is the difference between the HFC emissions (in thousand metric tons of CO2 equivalent) of 2005 and HFC emissions (in thousand metric tons of CO2 equivalent) of 2008 in Netherlands?
Make the answer very short. -869.3. What is the difference between the HFC emissions (in thousand metric tons of CO2 equivalent) of 1990 and HFC emissions (in thousand metric tons of CO2 equivalent) of 2000 in New Zealand?
Provide a succinct answer. -347.1. What is the difference between the HFC emissions (in thousand metric tons of CO2 equivalent) of 1990 and HFC emissions (in thousand metric tons of CO2 equivalent) of 2005 in New Zealand?
Give a very brief answer. -721.5. What is the difference between the HFC emissions (in thousand metric tons of CO2 equivalent) of 1990 and HFC emissions (in thousand metric tons of CO2 equivalent) of 2008 in New Zealand?
Offer a terse response. -971.2. What is the difference between the HFC emissions (in thousand metric tons of CO2 equivalent) in 2000 and HFC emissions (in thousand metric tons of CO2 equivalent) in 2005 in New Zealand?
Provide a short and direct response. -374.4. What is the difference between the HFC emissions (in thousand metric tons of CO2 equivalent) of 2000 and HFC emissions (in thousand metric tons of CO2 equivalent) of 2008 in New Zealand?
Give a very brief answer. -624.1. What is the difference between the HFC emissions (in thousand metric tons of CO2 equivalent) of 2005 and HFC emissions (in thousand metric tons of CO2 equivalent) of 2008 in New Zealand?
Ensure brevity in your answer.  -249.7. What is the difference between the HFC emissions (in thousand metric tons of CO2 equivalent) of 1990 and HFC emissions (in thousand metric tons of CO2 equivalent) of 2000 in Poland?
Provide a succinct answer. -667.1. What is the difference between the HFC emissions (in thousand metric tons of CO2 equivalent) in 1990 and HFC emissions (in thousand metric tons of CO2 equivalent) in 2005 in Poland?
Give a very brief answer. -1736.6. What is the difference between the HFC emissions (in thousand metric tons of CO2 equivalent) in 1990 and HFC emissions (in thousand metric tons of CO2 equivalent) in 2008 in Poland?
Offer a terse response. -2377.9. What is the difference between the HFC emissions (in thousand metric tons of CO2 equivalent) in 2000 and HFC emissions (in thousand metric tons of CO2 equivalent) in 2005 in Poland?
Ensure brevity in your answer.  -1069.5. What is the difference between the HFC emissions (in thousand metric tons of CO2 equivalent) of 2000 and HFC emissions (in thousand metric tons of CO2 equivalent) of 2008 in Poland?
Your answer should be very brief. -1710.8. What is the difference between the HFC emissions (in thousand metric tons of CO2 equivalent) of 2005 and HFC emissions (in thousand metric tons of CO2 equivalent) of 2008 in Poland?
Provide a succinct answer. -641.3. What is the ratio of the HFC emissions (in thousand metric tons of CO2 equivalent) in 1990 in Luxembourg to that in Malaysia?
Provide a short and direct response. 1. What is the ratio of the HFC emissions (in thousand metric tons of CO2 equivalent) of 2000 in Luxembourg to that in Malaysia?
Your answer should be very brief. 7.41. What is the ratio of the HFC emissions (in thousand metric tons of CO2 equivalent) of 2005 in Luxembourg to that in Malaysia?
Your answer should be very brief. 3.81. What is the ratio of the HFC emissions (in thousand metric tons of CO2 equivalent) in 2008 in Luxembourg to that in Malaysia?
Give a very brief answer. 3.35. What is the ratio of the HFC emissions (in thousand metric tons of CO2 equivalent) in 2000 in Luxembourg to that in Mexico?
Ensure brevity in your answer.  0.02. What is the ratio of the HFC emissions (in thousand metric tons of CO2 equivalent) of 2005 in Luxembourg to that in Mexico?
Provide a succinct answer. 0.01. What is the ratio of the HFC emissions (in thousand metric tons of CO2 equivalent) of 2008 in Luxembourg to that in Mexico?
Provide a succinct answer. 0.01. What is the ratio of the HFC emissions (in thousand metric tons of CO2 equivalent) of 2000 in Luxembourg to that in Netherlands?
Your answer should be compact. 0.01. What is the ratio of the HFC emissions (in thousand metric tons of CO2 equivalent) of 2005 in Luxembourg to that in Netherlands?
Keep it short and to the point. 0.03. What is the ratio of the HFC emissions (in thousand metric tons of CO2 equivalent) in 2008 in Luxembourg to that in Netherlands?
Give a very brief answer. 0.03. What is the ratio of the HFC emissions (in thousand metric tons of CO2 equivalent) in 2000 in Luxembourg to that in New Zealand?
Keep it short and to the point. 0.15. What is the ratio of the HFC emissions (in thousand metric tons of CO2 equivalent) in 2005 in Luxembourg to that in New Zealand?
Keep it short and to the point. 0.14. What is the ratio of the HFC emissions (in thousand metric tons of CO2 equivalent) of 2008 in Luxembourg to that in New Zealand?
Your response must be concise. 0.14. What is the ratio of the HFC emissions (in thousand metric tons of CO2 equivalent) in 2000 in Luxembourg to that in Poland?
Make the answer very short. 0.08. What is the ratio of the HFC emissions (in thousand metric tons of CO2 equivalent) in 2005 in Luxembourg to that in Poland?
Give a very brief answer. 0.06. What is the ratio of the HFC emissions (in thousand metric tons of CO2 equivalent) in 2008 in Luxembourg to that in Poland?
Your answer should be very brief. 0.06. What is the ratio of the HFC emissions (in thousand metric tons of CO2 equivalent) of 2000 in Malaysia to that in Mexico?
Provide a short and direct response. 0. What is the ratio of the HFC emissions (in thousand metric tons of CO2 equivalent) in 2005 in Malaysia to that in Mexico?
Your response must be concise. 0. What is the ratio of the HFC emissions (in thousand metric tons of CO2 equivalent) of 2008 in Malaysia to that in Mexico?
Provide a succinct answer. 0. What is the ratio of the HFC emissions (in thousand metric tons of CO2 equivalent) in 1990 in Malaysia to that in Netherlands?
Offer a very short reply. 0. What is the ratio of the HFC emissions (in thousand metric tons of CO2 equivalent) of 2000 in Malaysia to that in Netherlands?
Keep it short and to the point. 0. What is the ratio of the HFC emissions (in thousand metric tons of CO2 equivalent) in 2005 in Malaysia to that in Netherlands?
Give a very brief answer. 0.01. What is the ratio of the HFC emissions (in thousand metric tons of CO2 equivalent) of 2008 in Malaysia to that in Netherlands?
Give a very brief answer. 0.01. What is the ratio of the HFC emissions (in thousand metric tons of CO2 equivalent) in 1990 in Malaysia to that in New Zealand?
Provide a succinct answer. 0.5. What is the ratio of the HFC emissions (in thousand metric tons of CO2 equivalent) of 2000 in Malaysia to that in New Zealand?
Ensure brevity in your answer.  0.02. What is the ratio of the HFC emissions (in thousand metric tons of CO2 equivalent) of 2005 in Malaysia to that in New Zealand?
Make the answer very short. 0.04. What is the ratio of the HFC emissions (in thousand metric tons of CO2 equivalent) of 2008 in Malaysia to that in New Zealand?
Ensure brevity in your answer.  0.04. What is the ratio of the HFC emissions (in thousand metric tons of CO2 equivalent) of 2000 in Malaysia to that in Poland?
Make the answer very short. 0.01. What is the ratio of the HFC emissions (in thousand metric tons of CO2 equivalent) of 2005 in Malaysia to that in Poland?
Your answer should be very brief. 0.01. What is the ratio of the HFC emissions (in thousand metric tons of CO2 equivalent) in 2008 in Malaysia to that in Poland?
Make the answer very short. 0.02. What is the ratio of the HFC emissions (in thousand metric tons of CO2 equivalent) of 1990 in Mexico to that in Netherlands?
Your response must be concise. 0.57. What is the ratio of the HFC emissions (in thousand metric tons of CO2 equivalent) in 2000 in Mexico to that in Netherlands?
Give a very brief answer. 0.54. What is the ratio of the HFC emissions (in thousand metric tons of CO2 equivalent) in 2005 in Mexico to that in Netherlands?
Give a very brief answer. 2.26. What is the ratio of the HFC emissions (in thousand metric tons of CO2 equivalent) in 2008 in Mexico to that in Netherlands?
Offer a terse response. 2.21. What is the ratio of the HFC emissions (in thousand metric tons of CO2 equivalent) in 1990 in Mexico to that in New Zealand?
Offer a terse response. 7976.5. What is the ratio of the HFC emissions (in thousand metric tons of CO2 equivalent) of 2000 in Mexico to that in New Zealand?
Offer a very short reply. 9.64. What is the ratio of the HFC emissions (in thousand metric tons of CO2 equivalent) in 2005 in Mexico to that in New Zealand?
Provide a succinct answer. 9.78. What is the ratio of the HFC emissions (in thousand metric tons of CO2 equivalent) of 2008 in Mexico to that in New Zealand?
Provide a succinct answer. 9.06. What is the ratio of the HFC emissions (in thousand metric tons of CO2 equivalent) of 1990 in Mexico to that in Poland?
Keep it short and to the point. 1.60e+04. What is the ratio of the HFC emissions (in thousand metric tons of CO2 equivalent) in 2000 in Mexico to that in Poland?
Your response must be concise. 5.02. What is the ratio of the HFC emissions (in thousand metric tons of CO2 equivalent) of 2005 in Mexico to that in Poland?
Make the answer very short. 4.06. What is the ratio of the HFC emissions (in thousand metric tons of CO2 equivalent) of 2008 in Mexico to that in Poland?
Ensure brevity in your answer.  3.7. What is the ratio of the HFC emissions (in thousand metric tons of CO2 equivalent) of 1990 in Netherlands to that in New Zealand?
Ensure brevity in your answer.  1.40e+04. What is the ratio of the HFC emissions (in thousand metric tons of CO2 equivalent) of 2000 in Netherlands to that in New Zealand?
Keep it short and to the point. 17.85. What is the ratio of the HFC emissions (in thousand metric tons of CO2 equivalent) in 2005 in Netherlands to that in New Zealand?
Your answer should be compact. 4.32. What is the ratio of the HFC emissions (in thousand metric tons of CO2 equivalent) in 2008 in Netherlands to that in New Zealand?
Make the answer very short. 4.11. What is the ratio of the HFC emissions (in thousand metric tons of CO2 equivalent) of 1990 in Netherlands to that in Poland?
Keep it short and to the point. 2.79e+04. What is the ratio of the HFC emissions (in thousand metric tons of CO2 equivalent) of 2000 in Netherlands to that in Poland?
Keep it short and to the point. 9.29. What is the ratio of the HFC emissions (in thousand metric tons of CO2 equivalent) in 2005 in Netherlands to that in Poland?
Your answer should be compact. 1.8. What is the ratio of the HFC emissions (in thousand metric tons of CO2 equivalent) in 2008 in Netherlands to that in Poland?
Offer a very short reply. 1.68. What is the ratio of the HFC emissions (in thousand metric tons of CO2 equivalent) of 1990 in New Zealand to that in Poland?
Your response must be concise. 2. What is the ratio of the HFC emissions (in thousand metric tons of CO2 equivalent) of 2000 in New Zealand to that in Poland?
Offer a terse response. 0.52. What is the ratio of the HFC emissions (in thousand metric tons of CO2 equivalent) of 2005 in New Zealand to that in Poland?
Offer a very short reply. 0.42. What is the ratio of the HFC emissions (in thousand metric tons of CO2 equivalent) in 2008 in New Zealand to that in Poland?
Offer a terse response. 0.41. What is the difference between the highest and the second highest HFC emissions (in thousand metric tons of CO2 equivalent) of 1990?
Offer a terse response. 1197.6. What is the difference between the highest and the second highest HFC emissions (in thousand metric tons of CO2 equivalent) in 2000?
Your response must be concise. 2853.1. What is the difference between the highest and the second highest HFC emissions (in thousand metric tons of CO2 equivalent) of 2005?
Offer a very short reply. 3939.4. What is the difference between the highest and the second highest HFC emissions (in thousand metric tons of CO2 equivalent) of 2008?
Your answer should be compact. 4808.1. What is the difference between the highest and the lowest HFC emissions (in thousand metric tons of CO2 equivalent) of 1990?
Offer a terse response. 2792.8. What is the difference between the highest and the lowest HFC emissions (in thousand metric tons of CO2 equivalent) of 2000?
Keep it short and to the point. 6193.5. What is the difference between the highest and the lowest HFC emissions (in thousand metric tons of CO2 equivalent) in 2005?
Keep it short and to the point. 7032.8. What is the difference between the highest and the lowest HFC emissions (in thousand metric tons of CO2 equivalent) of 2008?
Your response must be concise. 8757.7. 